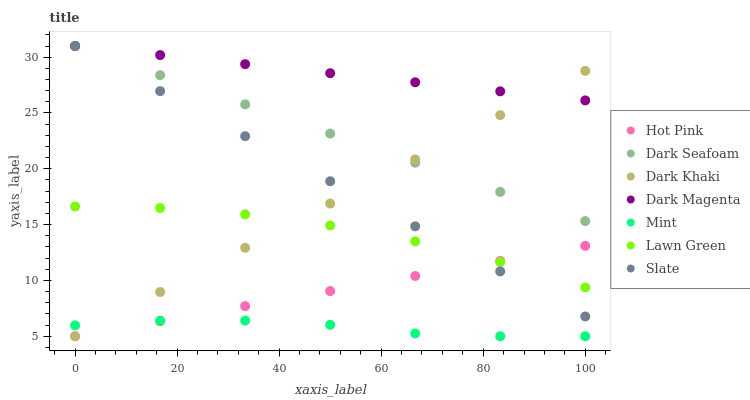Does Mint have the minimum area under the curve?
Answer yes or no. Yes. Does Dark Magenta have the maximum area under the curve?
Answer yes or no. Yes. Does Slate have the minimum area under the curve?
Answer yes or no. No. Does Slate have the maximum area under the curve?
Answer yes or no. No. Is Slate the smoothest?
Answer yes or no. Yes. Is Lawn Green the roughest?
Answer yes or no. Yes. Is Dark Magenta the smoothest?
Answer yes or no. No. Is Dark Magenta the roughest?
Answer yes or no. No. Does Hot Pink have the lowest value?
Answer yes or no. Yes. Does Slate have the lowest value?
Answer yes or no. No. Does Dark Seafoam have the highest value?
Answer yes or no. Yes. Does Hot Pink have the highest value?
Answer yes or no. No. Is Hot Pink less than Dark Seafoam?
Answer yes or no. Yes. Is Dark Seafoam greater than Mint?
Answer yes or no. Yes. Does Dark Khaki intersect Lawn Green?
Answer yes or no. Yes. Is Dark Khaki less than Lawn Green?
Answer yes or no. No. Is Dark Khaki greater than Lawn Green?
Answer yes or no. No. Does Hot Pink intersect Dark Seafoam?
Answer yes or no. No. 